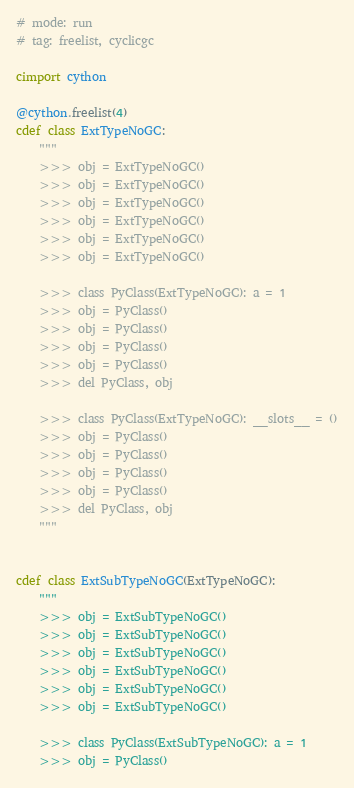Convert code to text. <code><loc_0><loc_0><loc_500><loc_500><_Cython_># mode: run
# tag: freelist, cyclicgc

cimport cython

@cython.freelist(4)
cdef class ExtTypeNoGC:
    """
    >>> obj = ExtTypeNoGC()
    >>> obj = ExtTypeNoGC()
    >>> obj = ExtTypeNoGC()
    >>> obj = ExtTypeNoGC()
    >>> obj = ExtTypeNoGC()
    >>> obj = ExtTypeNoGC()

    >>> class PyClass(ExtTypeNoGC): a = 1
    >>> obj = PyClass()
    >>> obj = PyClass()
    >>> obj = PyClass()
    >>> obj = PyClass()
    >>> del PyClass, obj

    >>> class PyClass(ExtTypeNoGC): __slots__ = ()
    >>> obj = PyClass()
    >>> obj = PyClass()
    >>> obj = PyClass()
    >>> obj = PyClass()
    >>> del PyClass, obj
    """


cdef class ExtSubTypeNoGC(ExtTypeNoGC):
    """
    >>> obj = ExtSubTypeNoGC()
    >>> obj = ExtSubTypeNoGC()
    >>> obj = ExtSubTypeNoGC()
    >>> obj = ExtSubTypeNoGC()
    >>> obj = ExtSubTypeNoGC()
    >>> obj = ExtSubTypeNoGC()

    >>> class PyClass(ExtSubTypeNoGC): a = 1
    >>> obj = PyClass()</code> 